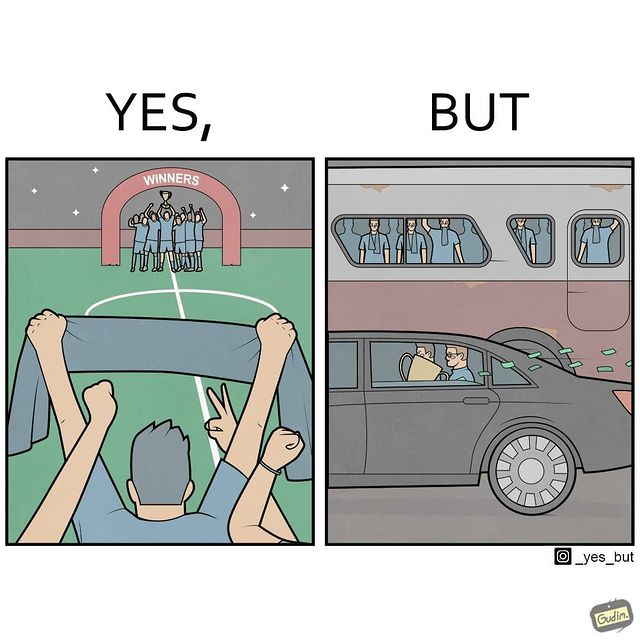Would you classify this image as satirical? Yes, this image is satirical. 